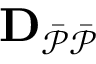Convert formula to latex. <formula><loc_0><loc_0><loc_500><loc_500>D _ { \mathcal { \ B a r { P } \ B a r { P } } }</formula> 